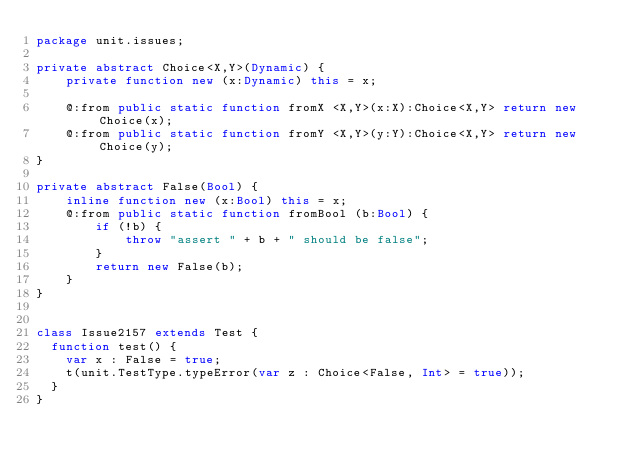<code> <loc_0><loc_0><loc_500><loc_500><_Haxe_>package unit.issues;

private abstract Choice<X,Y>(Dynamic) {
    private function new (x:Dynamic) this = x;

    @:from public static function fromX <X,Y>(x:X):Choice<X,Y> return new Choice(x);
    @:from public static function fromY <X,Y>(y:Y):Choice<X,Y> return new Choice(y);
}

private abstract False(Bool) {
    inline function new (x:Bool) this = x;
    @:from public static function fromBool (b:Bool) {
        if (!b) {
            throw "assert " + b + " should be false";
        }
        return new False(b);
    }
}


class Issue2157 extends Test {
	function test() {
		var x : False = true;
		t(unit.TestType.typeError(var z : Choice<False, Int> = true));
	}
}</code> 